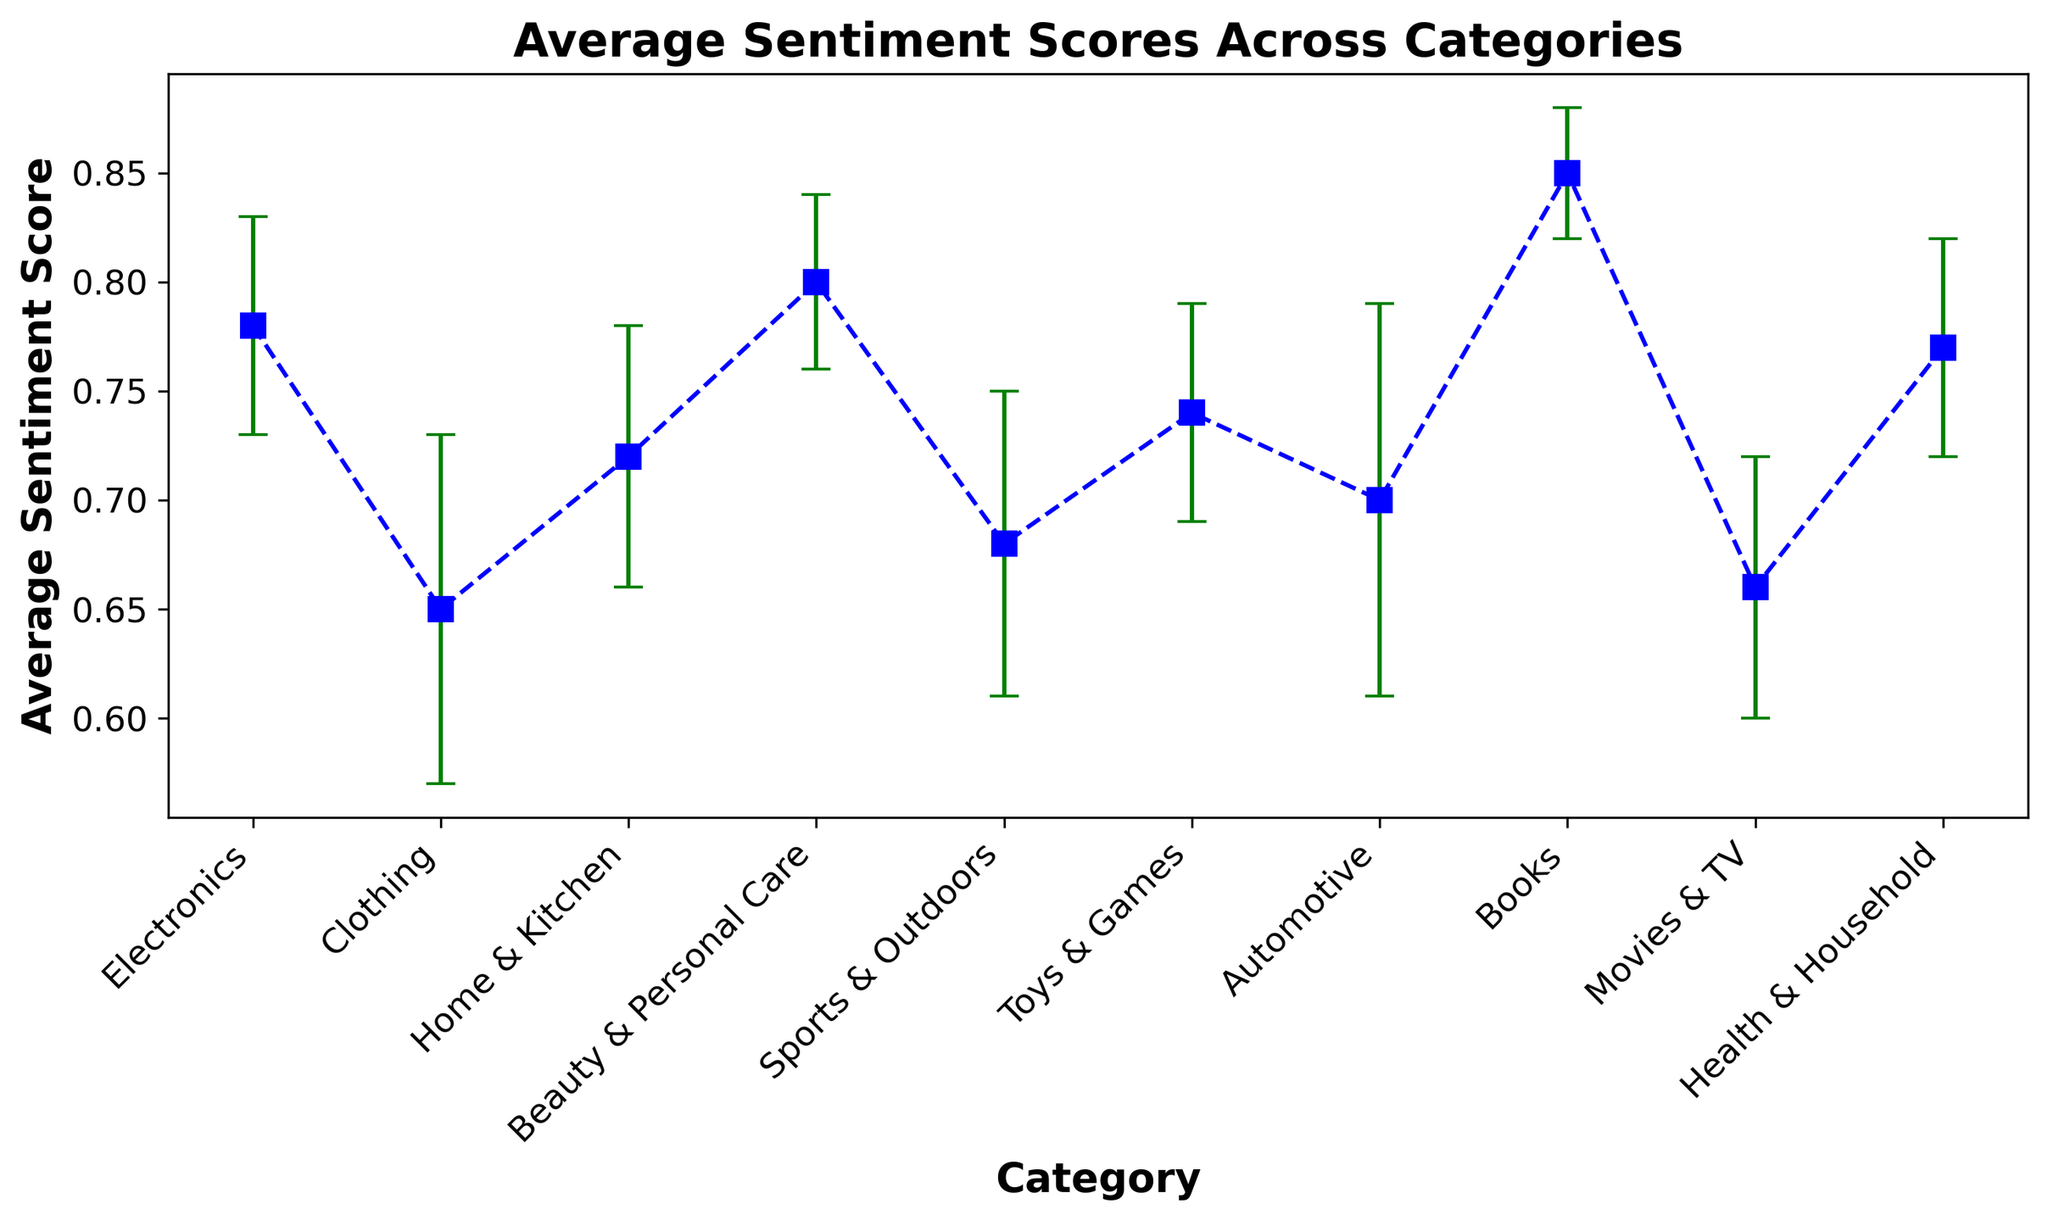Which category has the highest average sentiment score? By observing the y-values corresponding to each category on the errorbar plot, we can see that the category "Books" has the highest average sentiment score of 0.85, as it's the highest point on the y-axis.
Answer: Books What's the difference in average sentiment score between the category with the highest and the lowest score? First, identify the highest and lowest scores. The highest is for "Books" (0.85) and the lowest is for "Clothing" (0.65). The difference is calculated by subtracting the lowest score from the highest: 0.85 - 0.65.
Answer: 0.20 Which category has the largest standard deviation in sentiment scores? By checking the error bars (vertical lines) that show the standard deviation for each category, the largest deviation is seen with "Automotive," which has a value of 0.09.
Answer: Automotive What is the average sentiment score for the categories "Electronics" and "Beauty & Personal Care"? To find the average sentiment score for these two categories, first add their scores: 0.78 (Electronics) + 0.80 (Beauty & Personal Care) = 1.58. Then divide by 2 to find the average: 1.58 / 2.
Answer: 0.79 Which category has a higher average sentiment score, "Movies & TV" or "Sports & Outdoors"? Comparing the y-axis values for these two categories, "Sports & Outdoors" has an average sentiment score of 0.68, whereas "Movies & TV" has an average sentiment score of 0.66. Therefore, "Sports & Outdoors" has a higher average score.
Answer: Sports & Outdoors What is the median average sentiment score of all categories? To find the median, list all average scores in ascending order (0.65, 0.66, 0.68, 0.70, 0.72, 0.74, 0.77, 0.78, 0.80, 0.85) and identify the middle value(s). With 10 values, the median is the average of the 5th and 6th values: (0.72 + 0.74) / 2.
Answer: 0.73 Which categories have an average sentiment score greater than 0.75? Compare each category's sentiment score with 0.75. The categories "Electronics" (0.78), "Beauty & Personal Care" (0.80), "Books" (0.85), and "Health & Household" (0.77) all have values greater than 0.75.
Answer: Electronics, Beauty & Personal Care, Books, Health & Household 